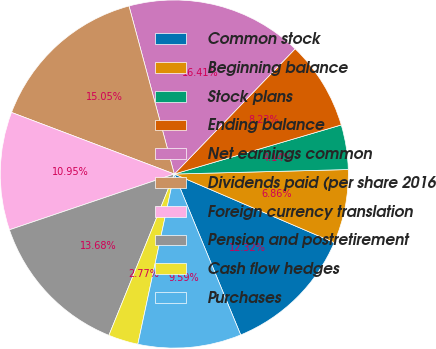Convert chart. <chart><loc_0><loc_0><loc_500><loc_500><pie_chart><fcel>Common stock<fcel>Beginning balance<fcel>Stock plans<fcel>Ending balance<fcel>Net earnings common<fcel>Dividends paid (per share 2016<fcel>Foreign currency translation<fcel>Pension and postretirement<fcel>Cash flow hedges<fcel>Purchases<nl><fcel>12.32%<fcel>6.86%<fcel>4.14%<fcel>8.23%<fcel>16.41%<fcel>15.05%<fcel>10.95%<fcel>13.68%<fcel>2.77%<fcel>9.59%<nl></chart> 